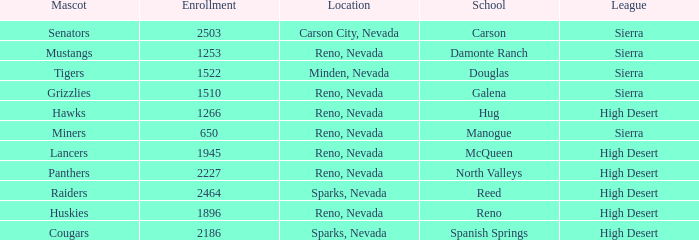Which leagues is the Galena school in? Sierra. 